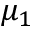Convert formula to latex. <formula><loc_0><loc_0><loc_500><loc_500>\mu _ { 1 }</formula> 